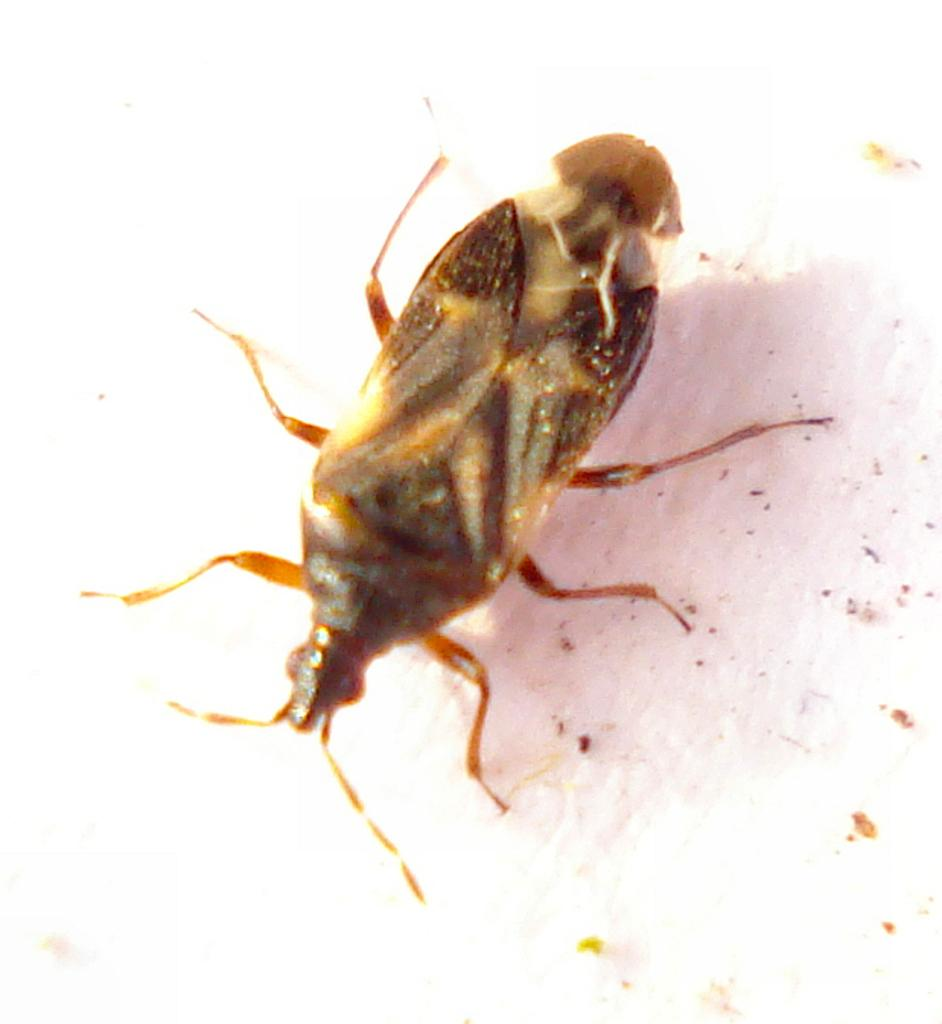What type of creature is present in the image? There is an insect in the image. Where is the insect located? The insect is on a platform. What type of ink is the insect using to make a decision in the image? There is no ink or decision-making process depicted in the image; it simply shows an insect on a platform. 